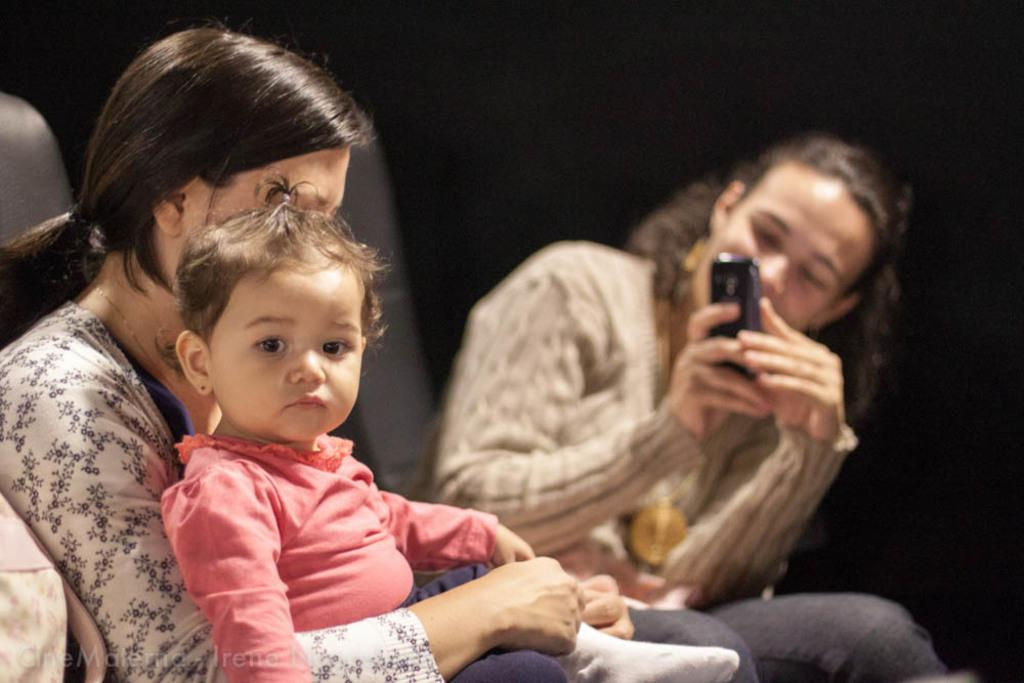What is the lady on the left side of the image doing? There is a lady sitting on the left side of the image. What is the lady holding on her lap? A baby is sitting on the lady's lap. What is the lady on the right side of the image doing? The lady on the right side of the image is taking a photograph. Can you describe the quality of the photograph being taken? The photograph being taken is blurry. What type of theory is the lady on the left side of the image discussing with the baby? There is no discussion of a theory in the image; the lady is simply sitting with the baby on her lap. What kind of haircut does the elbow on the right side of the image have? There is no elbow present in the image, and therefore no haircut can be attributed to it. 